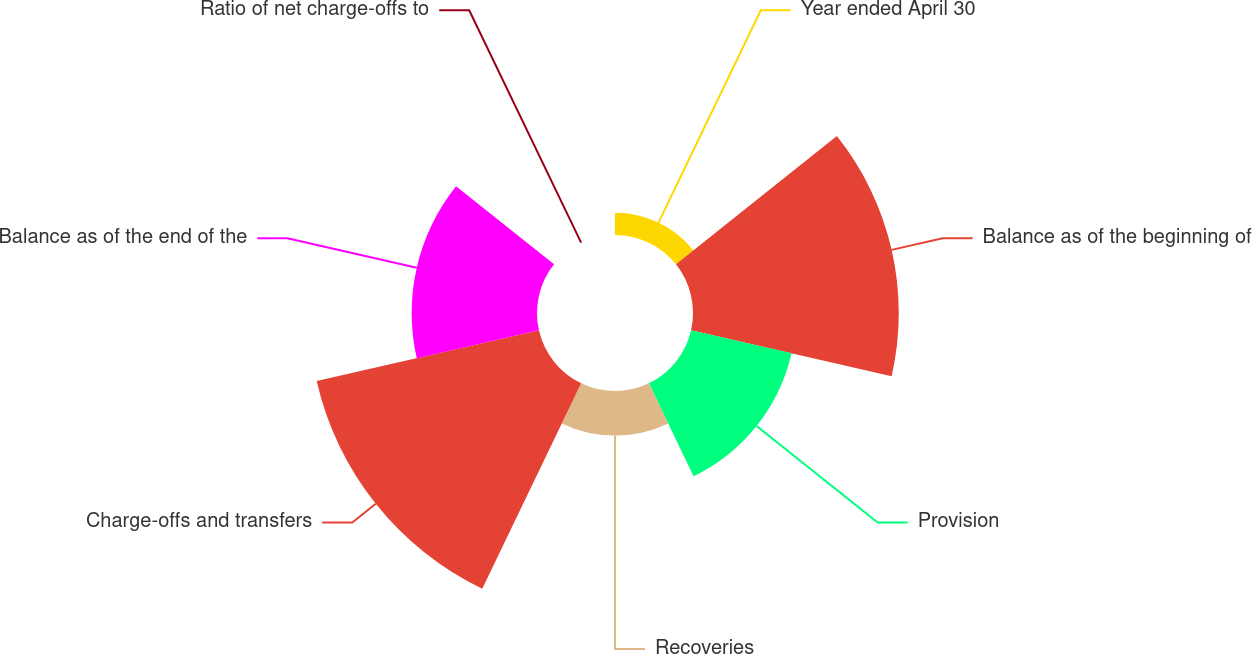Convert chart to OTSL. <chart><loc_0><loc_0><loc_500><loc_500><pie_chart><fcel>Year ended April 30<fcel>Balance as of the beginning of<fcel>Provision<fcel>Recoveries<fcel>Charge-offs and transfers<fcel>Balance as of the end of the<fcel>Ratio of net charge-offs to<nl><fcel>3.06%<fcel>28.22%<fcel>14.14%<fcel>6.12%<fcel>31.27%<fcel>17.19%<fcel>0.01%<nl></chart> 